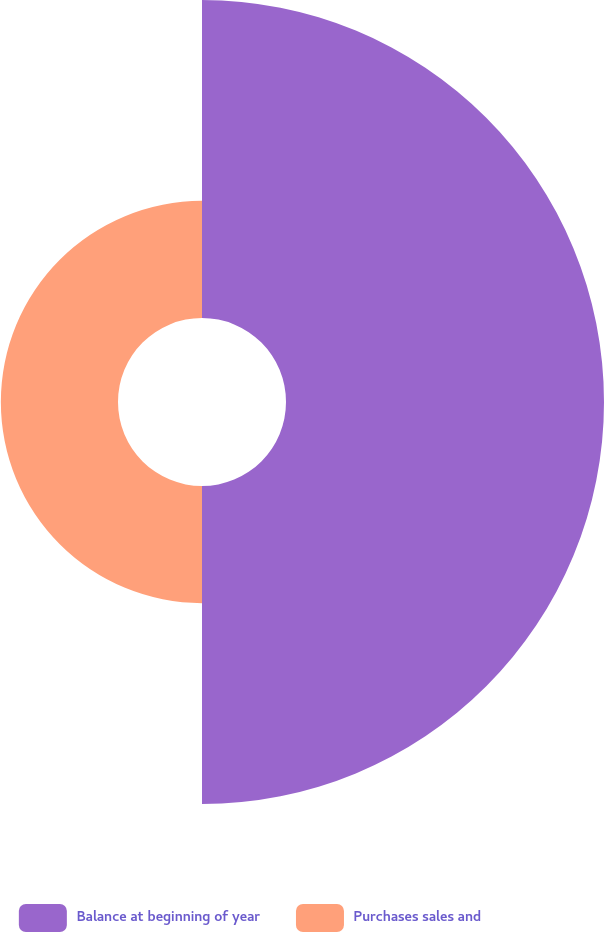Convert chart to OTSL. <chart><loc_0><loc_0><loc_500><loc_500><pie_chart><fcel>Balance at beginning of year<fcel>Purchases sales and<nl><fcel>73.08%<fcel>26.92%<nl></chart> 